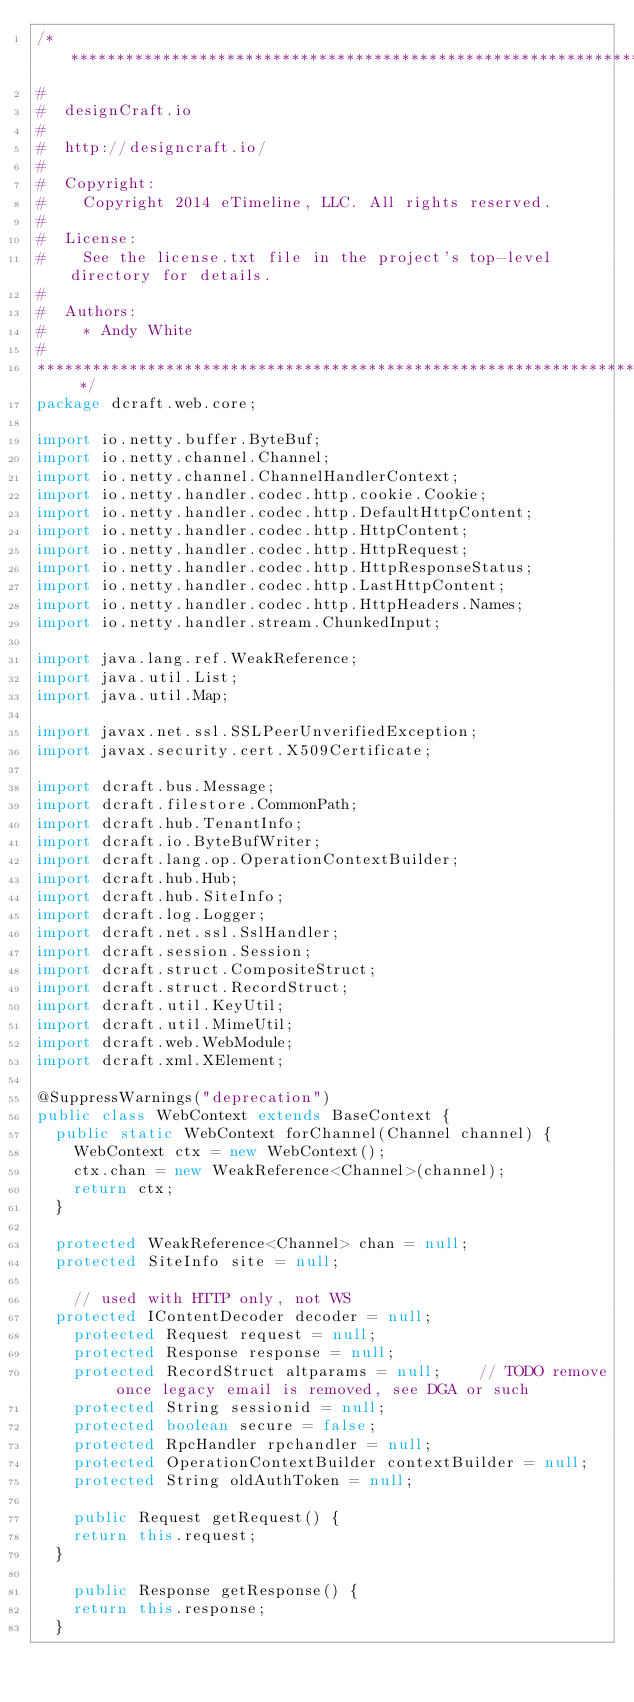<code> <loc_0><loc_0><loc_500><loc_500><_Java_>/* ************************************************************************
#
#  designCraft.io
#
#  http://designcraft.io/
#
#  Copyright:
#    Copyright 2014 eTimeline, LLC. All rights reserved.
#
#  License:
#    See the license.txt file in the project's top-level directory for details.
#
#  Authors:
#    * Andy White
#
************************************************************************ */
package dcraft.web.core;

import io.netty.buffer.ByteBuf;
import io.netty.channel.Channel;
import io.netty.channel.ChannelHandlerContext;
import io.netty.handler.codec.http.cookie.Cookie;
import io.netty.handler.codec.http.DefaultHttpContent;
import io.netty.handler.codec.http.HttpContent;
import io.netty.handler.codec.http.HttpRequest;
import io.netty.handler.codec.http.HttpResponseStatus;
import io.netty.handler.codec.http.LastHttpContent;
import io.netty.handler.codec.http.HttpHeaders.Names;
import io.netty.handler.stream.ChunkedInput;

import java.lang.ref.WeakReference;
import java.util.List;
import java.util.Map;

import javax.net.ssl.SSLPeerUnverifiedException;
import javax.security.cert.X509Certificate;

import dcraft.bus.Message;
import dcraft.filestore.CommonPath;
import dcraft.hub.TenantInfo;
import dcraft.io.ByteBufWriter;
import dcraft.lang.op.OperationContextBuilder;
import dcraft.hub.Hub;
import dcraft.hub.SiteInfo;
import dcraft.log.Logger;
import dcraft.net.ssl.SslHandler;
import dcraft.session.Session;
import dcraft.struct.CompositeStruct;
import dcraft.struct.RecordStruct;
import dcraft.util.KeyUtil;
import dcraft.util.MimeUtil;
import dcraft.web.WebModule;
import dcraft.xml.XElement;

@SuppressWarnings("deprecation")
public class WebContext extends BaseContext {
	public static WebContext forChannel(Channel channel) {
		WebContext ctx = new WebContext();
		ctx.chan = new WeakReference<Channel>(channel);
		return ctx;
	}
	
	protected WeakReference<Channel> chan = null;
	protected SiteInfo site = null;						
    
    // used with HTTP only, not WS
	protected IContentDecoder decoder = null;    	
    protected Request request = null;
    protected Response response = null;
    protected RecordStruct altparams = null;		// TODO remove once legacy email is removed, see DGA or such
    protected String sessionid = null;					
    protected boolean secure = false;
    protected RpcHandler rpchandler = null;
    protected OperationContextBuilder contextBuilder = null;
    protected String oldAuthToken = null;
    
    public Request getRequest() {
		return this.request;
	}
    
    public Response getResponse() {
		return this.response;
	}
    </code> 